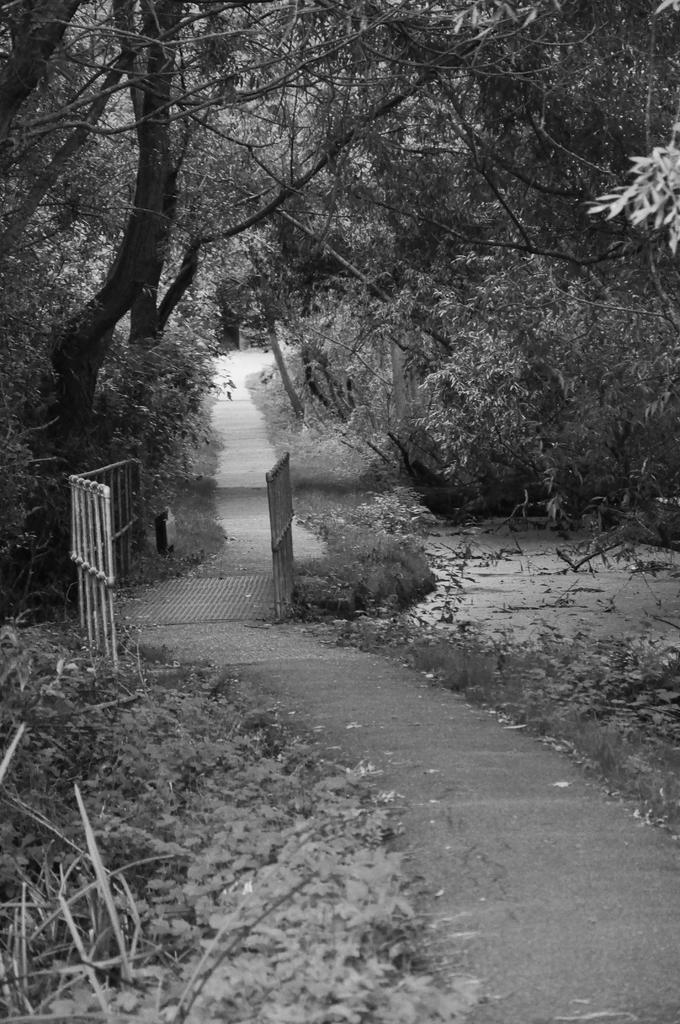What type of vegetation is present in the center of the image? There are trees, plants, and grass in the center of the image. What else can be seen in the center of the image besides vegetation? There are fences in the center of the image. What type of beetle can be seen crawling on the earth in the image? There is no beetle present in the image, and the term "earth" is not mentioned in the provided facts. 